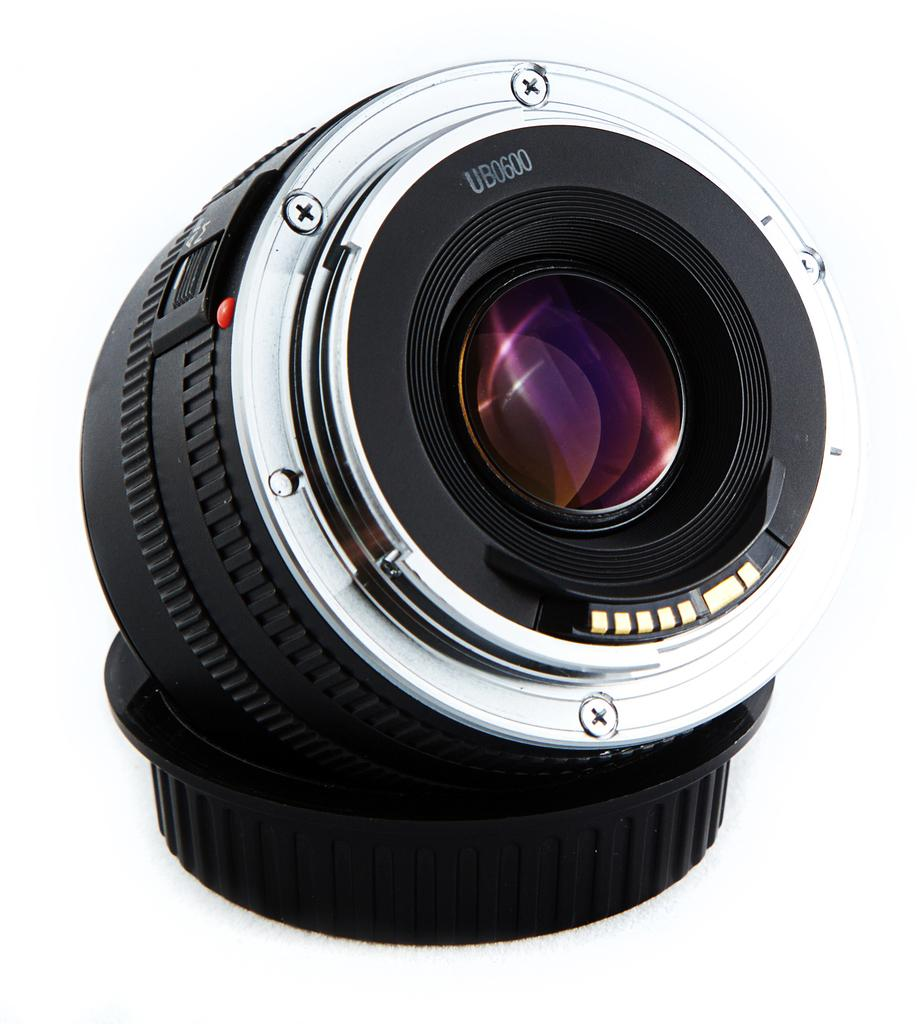What is the main subject of the image? The main subject of the image is a camera lens. What color is the background of the image? The background of the image is white. What type of flower is growing in the background of the image? There is no flower present in the image; the background is white. What ornament is hanging from the camera lens in the image? There is no ornament hanging from the camera lens in the image; only the camera lens is visible. 